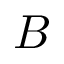<formula> <loc_0><loc_0><loc_500><loc_500>B</formula> 